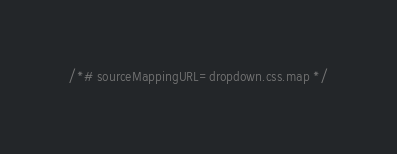<code> <loc_0><loc_0><loc_500><loc_500><_CSS_>/*# sourceMappingURL=dropdown.css.map */</code> 